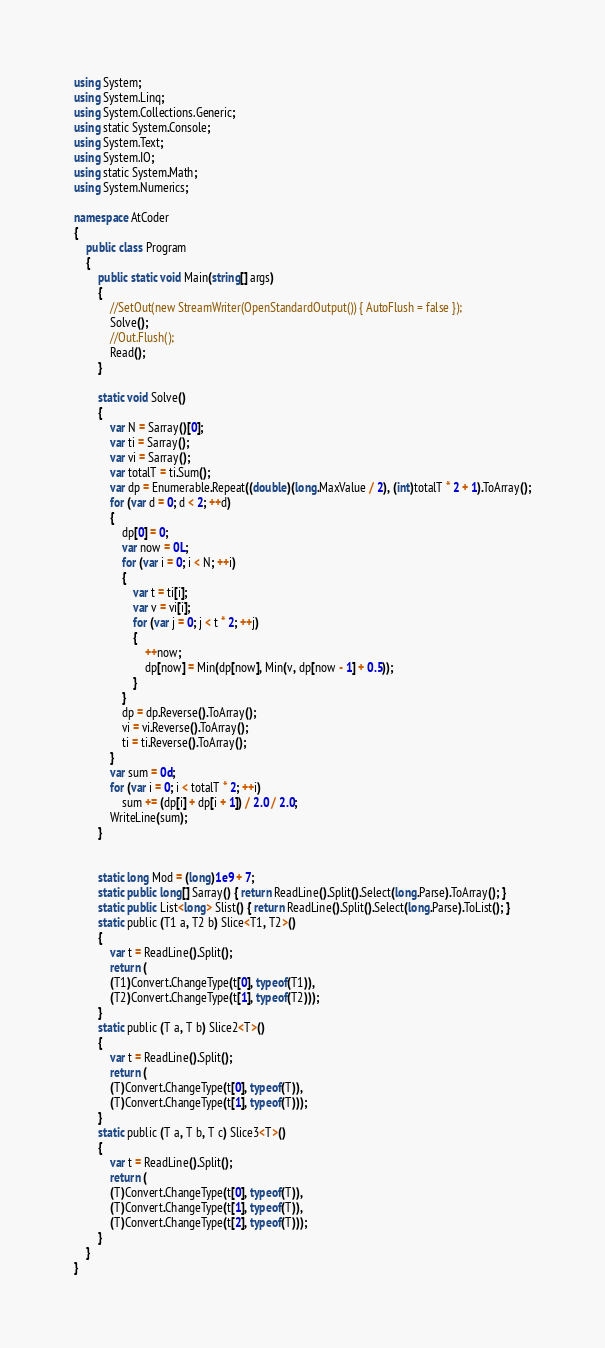Convert code to text. <code><loc_0><loc_0><loc_500><loc_500><_C#_>using System;
using System.Linq;
using System.Collections.Generic;
using static System.Console;
using System.Text;
using System.IO;
using static System.Math;
using System.Numerics;

namespace AtCoder
{
    public class Program
    {
        public static void Main(string[] args)
        {
            //SetOut(new StreamWriter(OpenStandardOutput()) { AutoFlush = false });
            Solve();
            //Out.Flush();
            Read();
        }

        static void Solve()
        {
            var N = Sarray()[0];
            var ti = Sarray();
            var vi = Sarray();
            var totalT = ti.Sum();
            var dp = Enumerable.Repeat((double)(long.MaxValue / 2), (int)totalT * 2 + 1).ToArray();
            for (var d = 0; d < 2; ++d)
            {
                dp[0] = 0;
                var now = 0L;
                for (var i = 0; i < N; ++i)
                {
                    var t = ti[i];
                    var v = vi[i];
                    for (var j = 0; j < t * 2; ++j)
                    {
                        ++now;
                        dp[now] = Min(dp[now], Min(v, dp[now - 1] + 0.5));
                    }
                }
                dp = dp.Reverse().ToArray();
                vi = vi.Reverse().ToArray();
                ti = ti.Reverse().ToArray();
            }
            var sum = 0d;
            for (var i = 0; i < totalT * 2; ++i)
                sum += (dp[i] + dp[i + 1]) / 2.0 / 2.0;
            WriteLine(sum);
        }


        static long Mod = (long)1e9 + 7;
        static public long[] Sarray() { return ReadLine().Split().Select(long.Parse).ToArray(); }
        static public List<long> Slist() { return ReadLine().Split().Select(long.Parse).ToList(); }
        static public (T1 a, T2 b) Slice<T1, T2>()
        {
            var t = ReadLine().Split();
            return (
            (T1)Convert.ChangeType(t[0], typeof(T1)),
            (T2)Convert.ChangeType(t[1], typeof(T2)));
        }
        static public (T a, T b) Slice2<T>()
        {
            var t = ReadLine().Split();
            return (
            (T)Convert.ChangeType(t[0], typeof(T)),
            (T)Convert.ChangeType(t[1], typeof(T)));
        }
        static public (T a, T b, T c) Slice3<T>()
        {
            var t = ReadLine().Split();
            return (
            (T)Convert.ChangeType(t[0], typeof(T)),
            (T)Convert.ChangeType(t[1], typeof(T)),
            (T)Convert.ChangeType(t[2], typeof(T)));
        }
    }
}</code> 